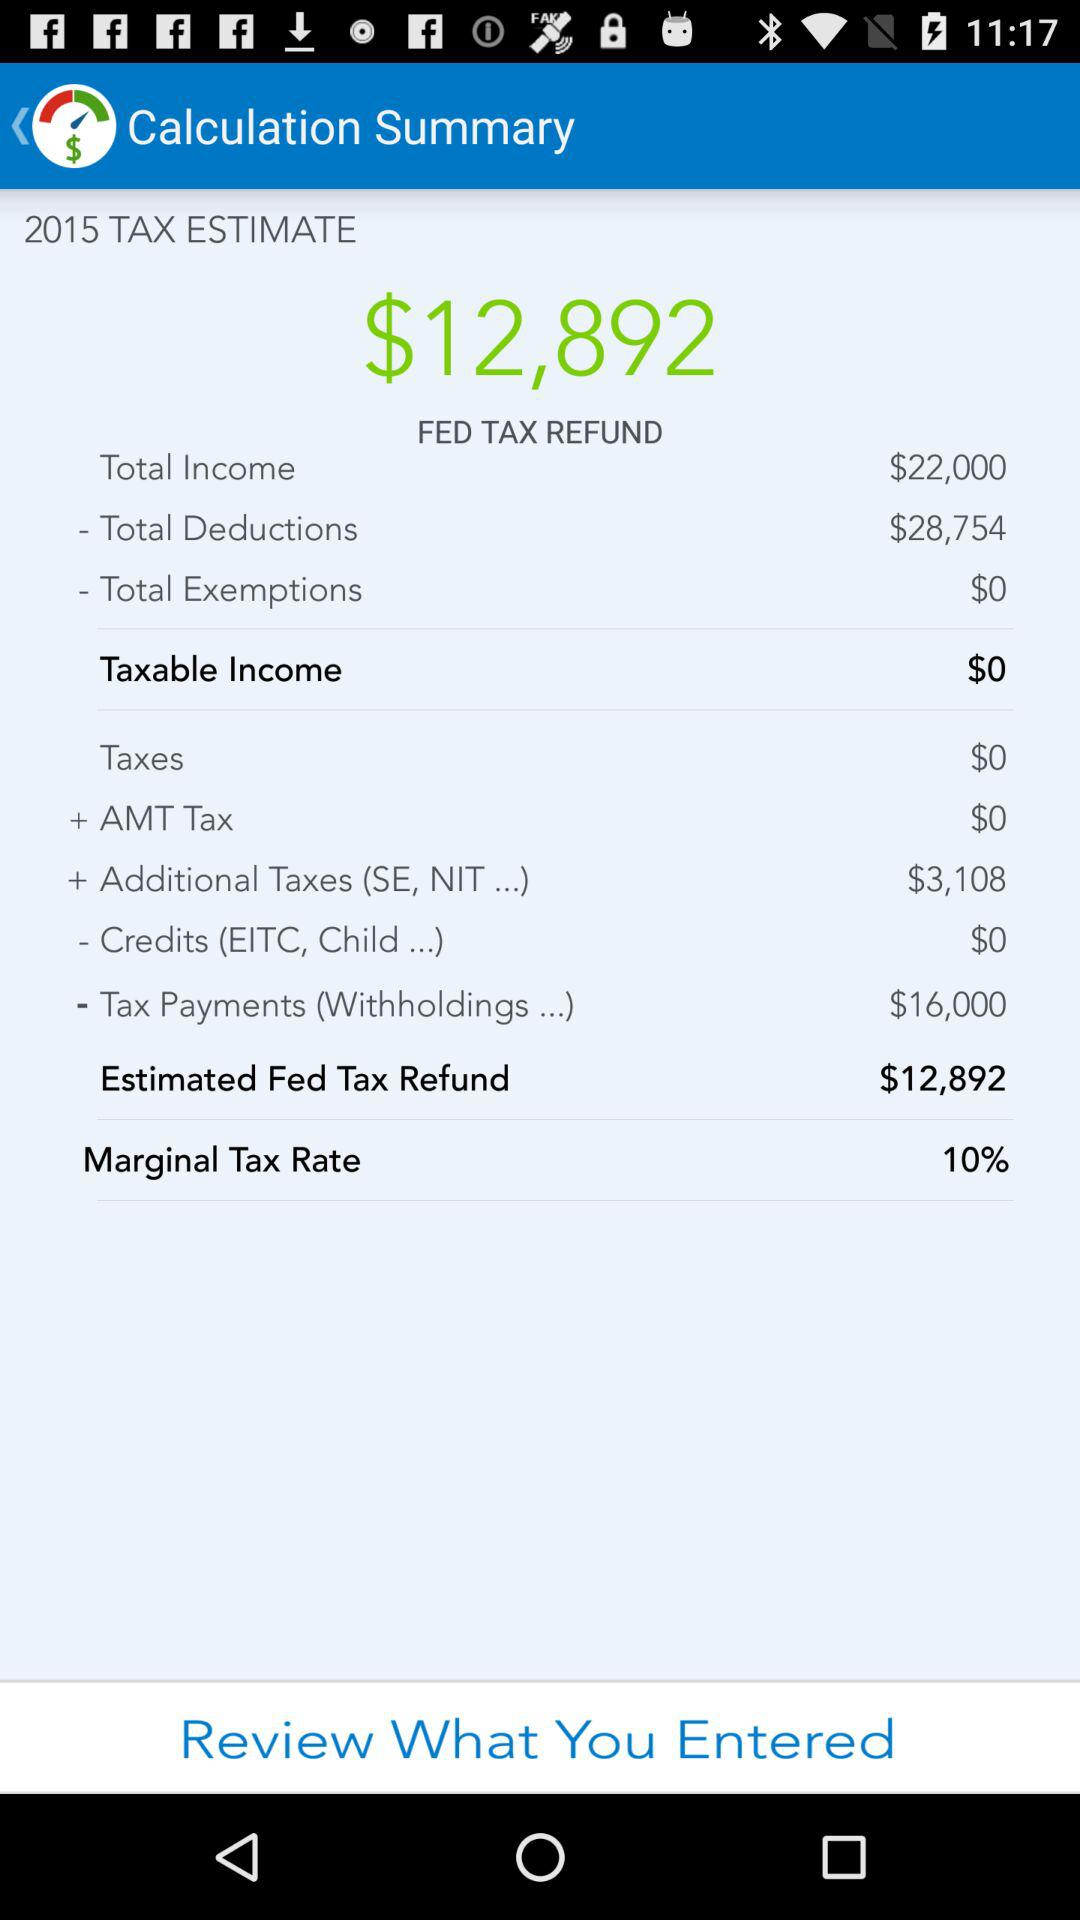What is the amount for additional taxes? The amount for the additional taxes is $3,108. 